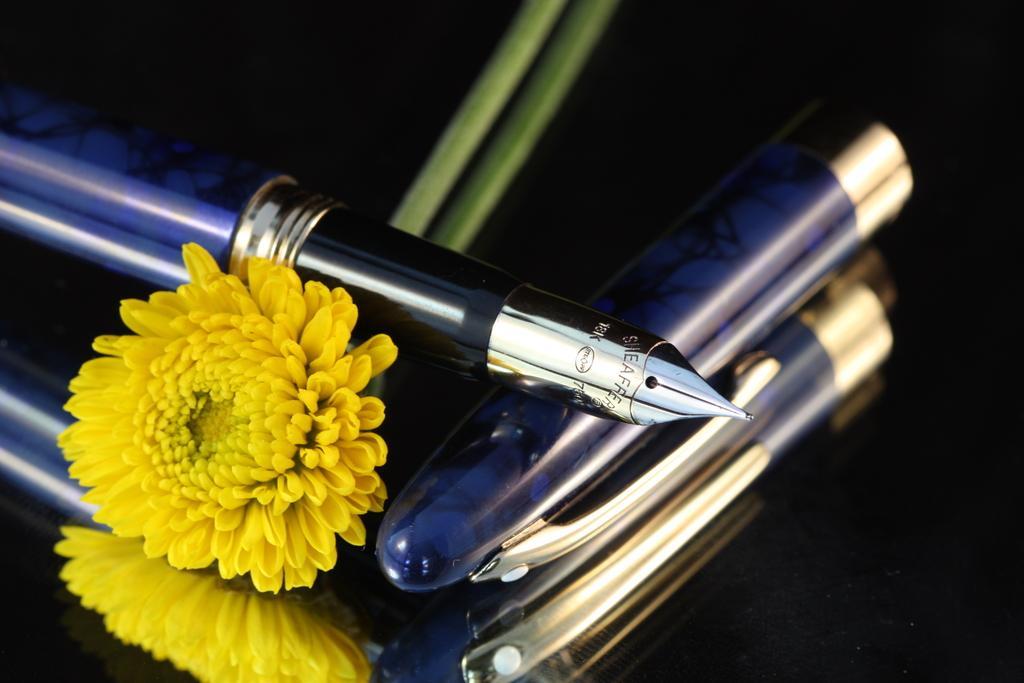Could you give a brief overview of what you see in this image? In this image we can see a flower, pen and a cap on the black surface and also we can see the reflection of those things. 